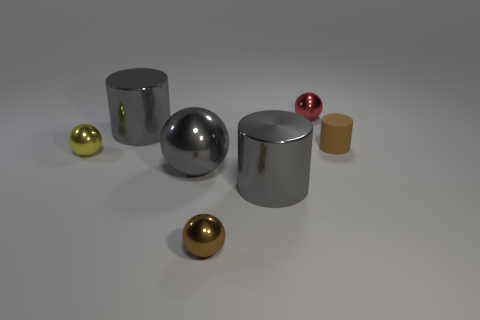Does the large cylinder that is behind the big gray ball have the same color as the big metal sphere?
Your answer should be compact. Yes. How many things are small metal things that are to the left of the tiny brown metallic sphere or spheres?
Offer a very short reply. 4. Is the number of yellow things in front of the small red metallic sphere greater than the number of brown cylinders that are in front of the yellow object?
Provide a short and direct response. Yes. Do the gray ball and the tiny cylinder have the same material?
Give a very brief answer. No. The thing that is on the left side of the big metal sphere and in front of the tiny cylinder has what shape?
Offer a terse response. Sphere. What shape is the tiny red object that is the same material as the large gray ball?
Ensure brevity in your answer.  Sphere. Are there any big cyan rubber things?
Provide a short and direct response. No. Is there a gray shiny sphere behind the big gray metal cylinder that is in front of the tiny brown rubber thing?
Give a very brief answer. Yes. Is the number of yellow spheres greater than the number of purple blocks?
Your answer should be very brief. Yes. There is a small cylinder; is it the same color as the tiny object that is in front of the small yellow shiny thing?
Give a very brief answer. Yes. 